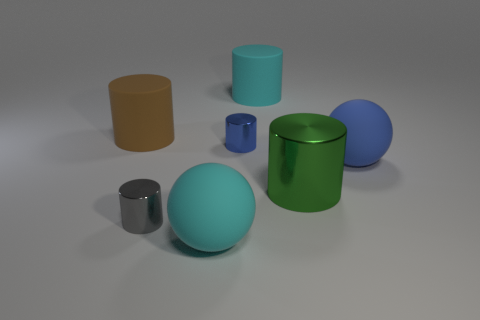The big cylinder in front of the thing that is to the right of the green thing is what color?
Your response must be concise. Green. Is the size of the gray cylinder the same as the blue cylinder?
Keep it short and to the point. Yes. Do the blue object in front of the blue cylinder and the small cylinder on the left side of the blue metallic thing have the same material?
Keep it short and to the point. No. What shape is the big rubber thing in front of the small cylinder that is in front of the blue object right of the cyan rubber cylinder?
Make the answer very short. Sphere. Are there more green metal things than large cyan rubber things?
Provide a succinct answer. No. Is there a tiny blue block?
Provide a succinct answer. No. How many objects are big cyan rubber objects that are in front of the big green cylinder or rubber things behind the big green shiny cylinder?
Give a very brief answer. 4. Are there fewer big blue matte things than purple matte cubes?
Ensure brevity in your answer.  No. There is a small gray cylinder; are there any tiny metallic things behind it?
Provide a succinct answer. Yes. Does the large brown object have the same material as the blue sphere?
Give a very brief answer. Yes. 